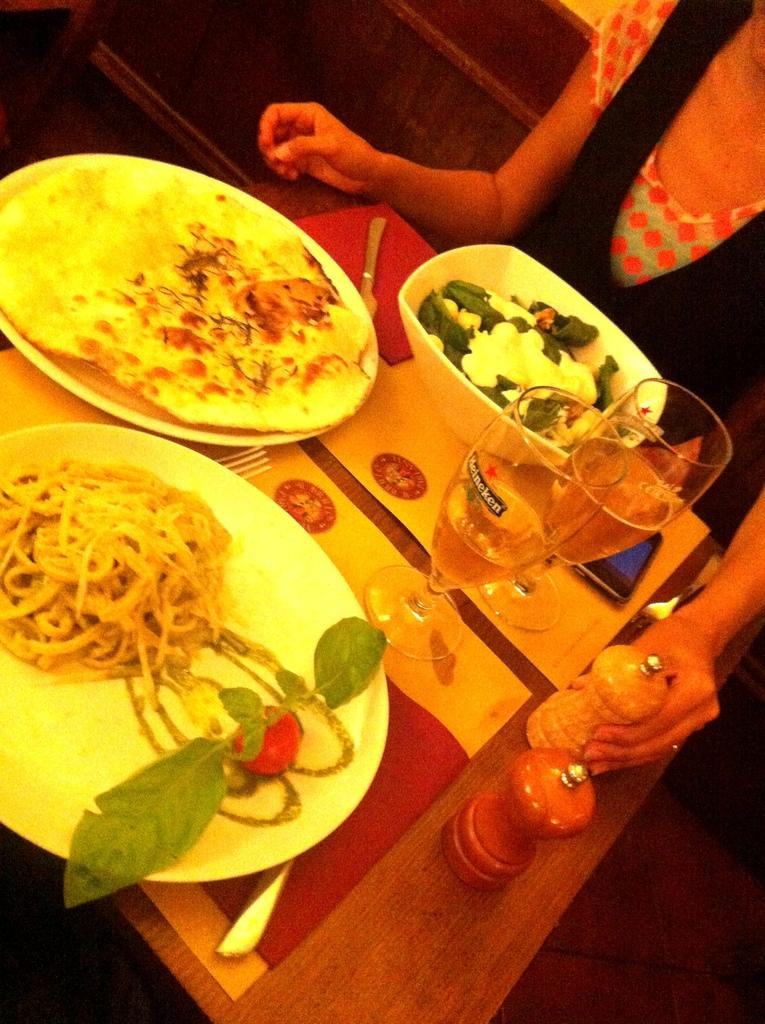What piece of furniture is present in the picture? There is a table in the picture. What items are placed on the table? There are plates, food items, glasses, and a spoon on the table. Who or what is visible in the picture? There is a person in the picture. What month is depicted in the picture? There is no indication of a specific month in the picture. How many apples are on the table in the picture? The provided facts do not mention apples being present on the table. What is the condition of the person's toes in the picture? There is no information about the person's toes in the picture. 